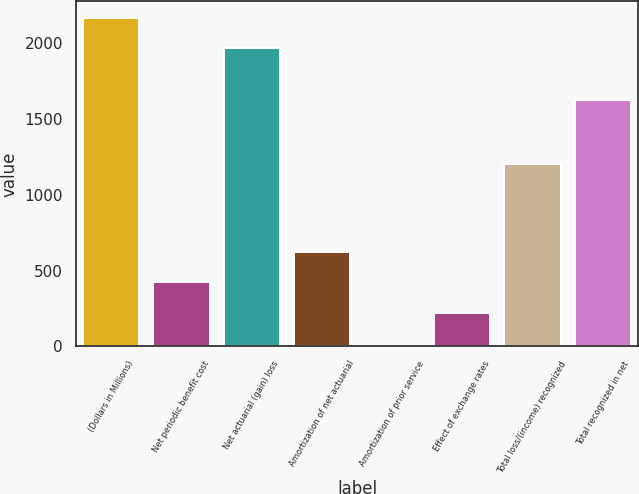Convert chart to OTSL. <chart><loc_0><loc_0><loc_500><loc_500><bar_chart><fcel>(Dollars in Millions)<fcel>Net periodic benefit cost<fcel>Net actuarial (gain) loss<fcel>Amortization of net actuarial<fcel>Amortization of prior service<fcel>Effect of exchange rates<fcel>Total loss/(income) recognized<fcel>Total recognized in net<nl><fcel>2166.5<fcel>422<fcel>1965<fcel>623.5<fcel>1<fcel>218<fcel>1202<fcel>1624<nl></chart> 